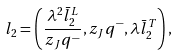<formula> <loc_0><loc_0><loc_500><loc_500>l _ { 2 } = \left ( \frac { \lambda ^ { 2 } \bar { l } _ { 2 } ^ { L } } { z _ { J } q ^ { - } } , z _ { J } q ^ { - } , \lambda \bar { l } _ { 2 } ^ { T } \right ) ,</formula> 